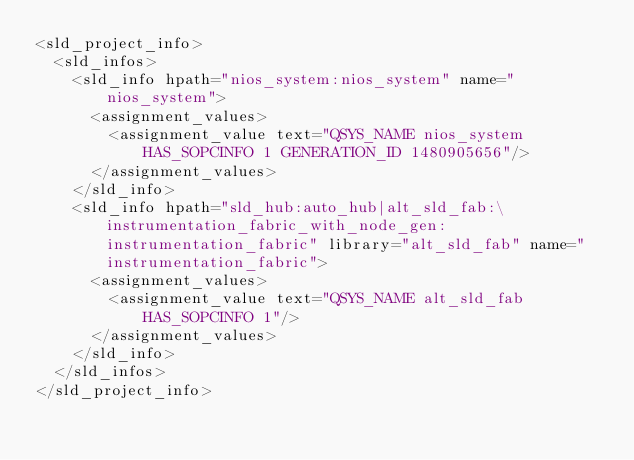<code> <loc_0><loc_0><loc_500><loc_500><_Scheme_><sld_project_info>
  <sld_infos>
    <sld_info hpath="nios_system:nios_system" name="nios_system">
      <assignment_values>
        <assignment_value text="QSYS_NAME nios_system HAS_SOPCINFO 1 GENERATION_ID 1480905656"/>
      </assignment_values>
    </sld_info>
    <sld_info hpath="sld_hub:auto_hub|alt_sld_fab:\instrumentation_fabric_with_node_gen:instrumentation_fabric" library="alt_sld_fab" name="instrumentation_fabric">
      <assignment_values>
        <assignment_value text="QSYS_NAME alt_sld_fab HAS_SOPCINFO 1"/>
      </assignment_values>
    </sld_info>
  </sld_infos>
</sld_project_info>
</code> 